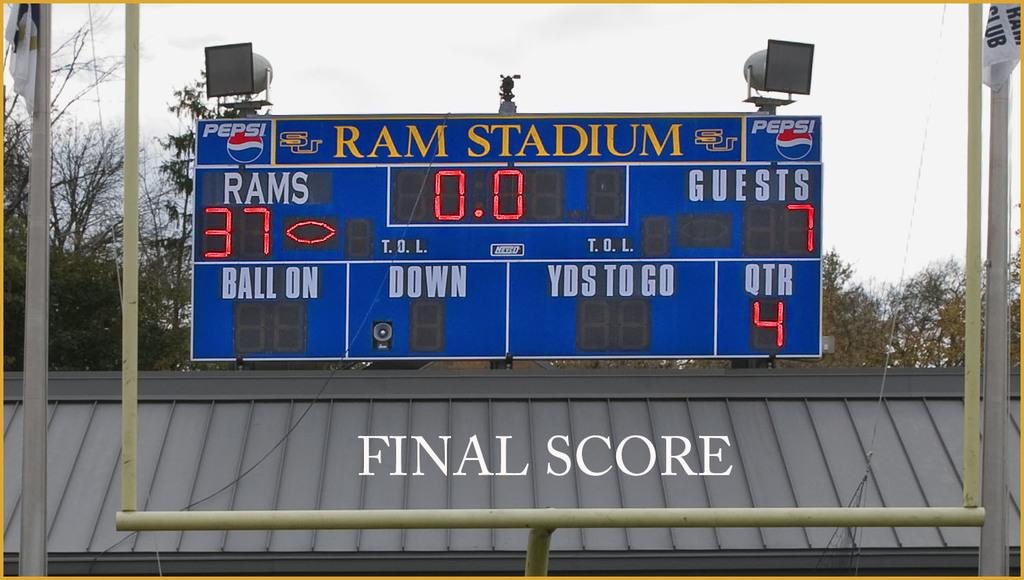<image>
Give a short and clear explanation of the subsequent image. Ram stadium scoreboard with a score of 37 Rams and 7 guests. 